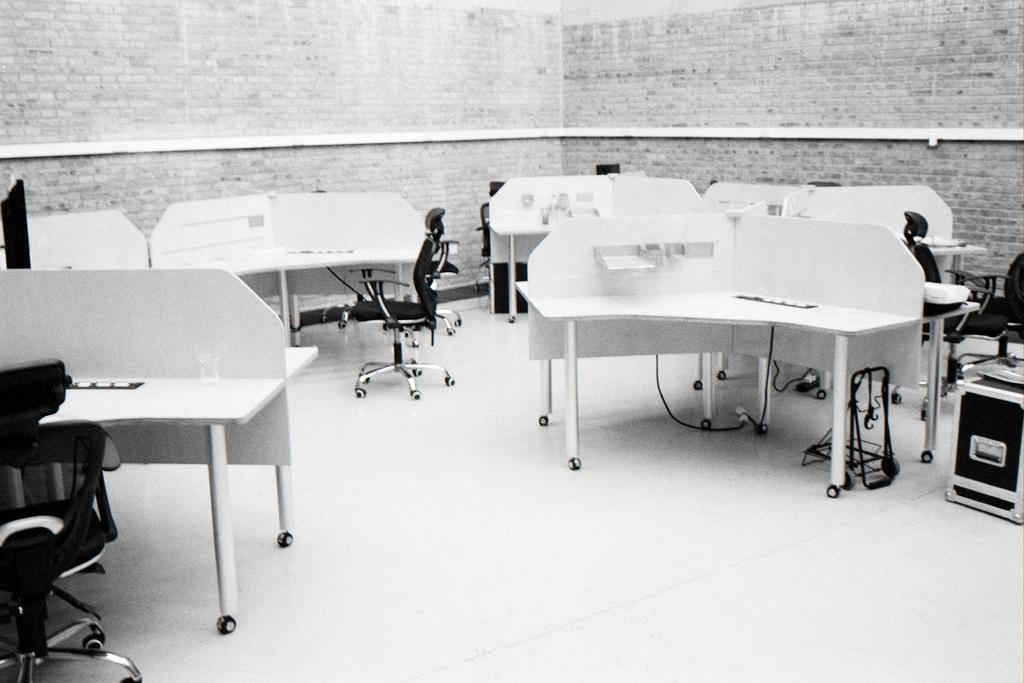What type of furniture is visible in the image? There are tables and chairs in the image. What news is being discussed by the chairs in the image? There is no news being discussed in the image, as chairs are inanimate objects and cannot engage in discussions. 